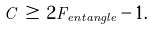Convert formula to latex. <formula><loc_0><loc_0><loc_500><loc_500>C \, \geq \, 2 F _ { e n t a n g l e } - 1 .</formula> 